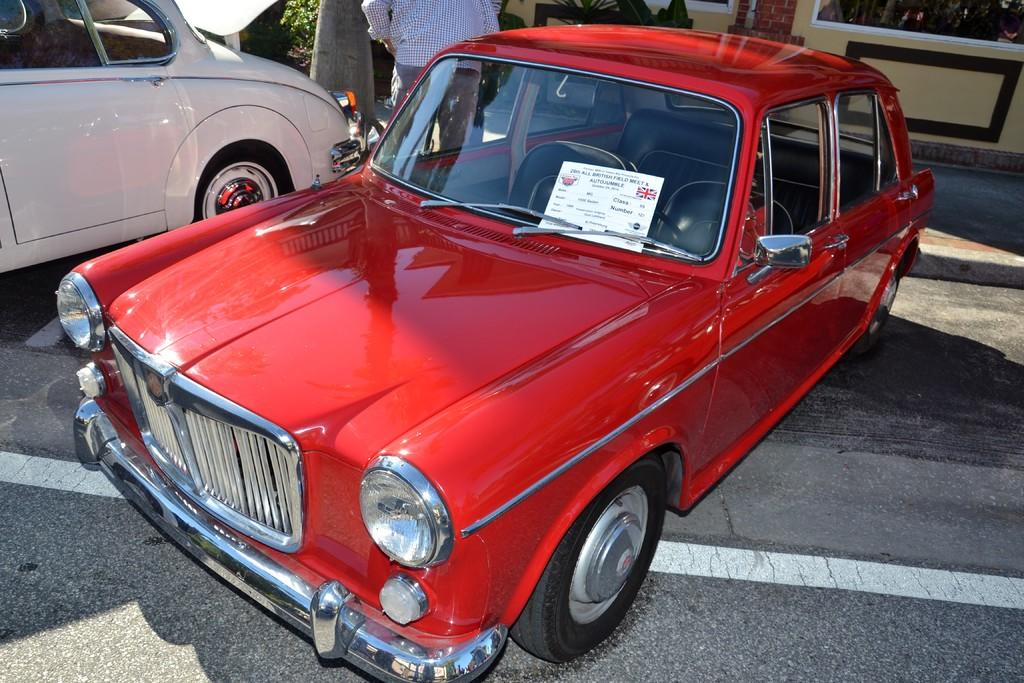What color is the car that is visible on the path in the image? There is a red car on the path in the image. What can be seen in the background of the image? In the background, there is a person, a vehicle, a plant, a wall, and a walkway. Can you describe the type of vehicle in the background? Unfortunately, the type of vehicle in the background cannot be determined from the provided facts. How many caves can be seen in the image? There are no caves present in the image. What type of tree is growing near the red car? There is no tree visible in the image; only a plant in the background can be seen. 